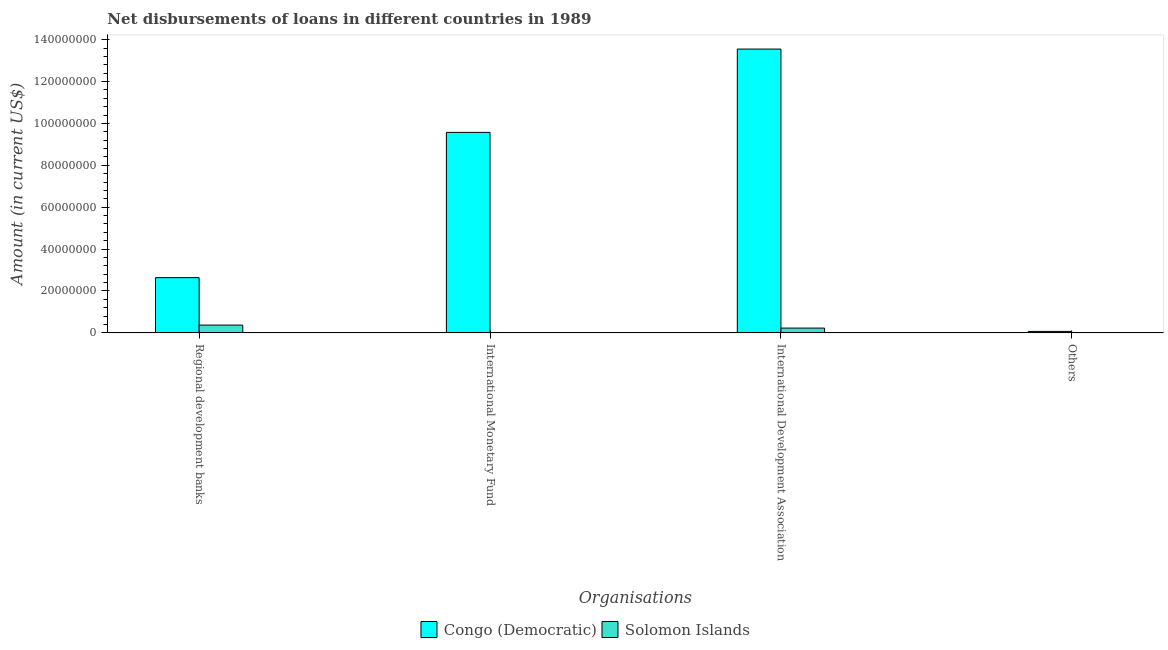Are the number of bars per tick equal to the number of legend labels?
Provide a short and direct response. No. What is the label of the 4th group of bars from the left?
Keep it short and to the point. Others. What is the amount of loan disimbursed by other organisations in Congo (Democratic)?
Offer a very short reply. 6.95e+05. Across all countries, what is the maximum amount of loan disimbursed by other organisations?
Make the answer very short. 6.95e+05. Across all countries, what is the minimum amount of loan disimbursed by regional development banks?
Keep it short and to the point. 3.71e+06. In which country was the amount of loan disimbursed by other organisations maximum?
Keep it short and to the point. Congo (Democratic). What is the total amount of loan disimbursed by regional development banks in the graph?
Provide a succinct answer. 3.01e+07. What is the difference between the amount of loan disimbursed by regional development banks in Solomon Islands and that in Congo (Democratic)?
Ensure brevity in your answer.  -2.27e+07. What is the difference between the amount of loan disimbursed by international development association in Congo (Democratic) and the amount of loan disimbursed by international monetary fund in Solomon Islands?
Your answer should be very brief. 1.35e+08. What is the average amount of loan disimbursed by regional development banks per country?
Provide a short and direct response. 1.50e+07. What is the difference between the amount of loan disimbursed by international development association and amount of loan disimbursed by regional development banks in Congo (Democratic)?
Provide a short and direct response. 1.09e+08. In how many countries, is the amount of loan disimbursed by other organisations greater than 116000000 US$?
Provide a succinct answer. 0. What is the ratio of the amount of loan disimbursed by other organisations in Congo (Democratic) to that in Solomon Islands?
Make the answer very short. 9.79. Is the difference between the amount of loan disimbursed by international development association in Congo (Democratic) and Solomon Islands greater than the difference between the amount of loan disimbursed by other organisations in Congo (Democratic) and Solomon Islands?
Give a very brief answer. Yes. What is the difference between the highest and the second highest amount of loan disimbursed by international development association?
Provide a short and direct response. 1.33e+08. What is the difference between the highest and the lowest amount of loan disimbursed by international monetary fund?
Your response must be concise. 9.57e+07. Is it the case that in every country, the sum of the amount of loan disimbursed by other organisations and amount of loan disimbursed by international development association is greater than the sum of amount of loan disimbursed by international monetary fund and amount of loan disimbursed by regional development banks?
Make the answer very short. Yes. Is it the case that in every country, the sum of the amount of loan disimbursed by regional development banks and amount of loan disimbursed by international monetary fund is greater than the amount of loan disimbursed by international development association?
Provide a succinct answer. No. How many countries are there in the graph?
Give a very brief answer. 2. Are the values on the major ticks of Y-axis written in scientific E-notation?
Keep it short and to the point. No. Does the graph contain any zero values?
Offer a very short reply. Yes. What is the title of the graph?
Give a very brief answer. Net disbursements of loans in different countries in 1989. Does "Bulgaria" appear as one of the legend labels in the graph?
Your answer should be very brief. No. What is the label or title of the X-axis?
Make the answer very short. Organisations. What is the label or title of the Y-axis?
Keep it short and to the point. Amount (in current US$). What is the Amount (in current US$) of Congo (Democratic) in Regional development banks?
Ensure brevity in your answer.  2.64e+07. What is the Amount (in current US$) of Solomon Islands in Regional development banks?
Keep it short and to the point. 3.71e+06. What is the Amount (in current US$) in Congo (Democratic) in International Monetary Fund?
Your answer should be compact. 9.57e+07. What is the Amount (in current US$) of Solomon Islands in International Monetary Fund?
Your answer should be very brief. 0. What is the Amount (in current US$) of Congo (Democratic) in International Development Association?
Your answer should be very brief. 1.35e+08. What is the Amount (in current US$) of Solomon Islands in International Development Association?
Offer a very short reply. 2.28e+06. What is the Amount (in current US$) in Congo (Democratic) in Others?
Keep it short and to the point. 6.95e+05. What is the Amount (in current US$) in Solomon Islands in Others?
Give a very brief answer. 7.10e+04. Across all Organisations, what is the maximum Amount (in current US$) of Congo (Democratic)?
Ensure brevity in your answer.  1.35e+08. Across all Organisations, what is the maximum Amount (in current US$) in Solomon Islands?
Your response must be concise. 3.71e+06. Across all Organisations, what is the minimum Amount (in current US$) of Congo (Democratic)?
Your answer should be compact. 6.95e+05. Across all Organisations, what is the minimum Amount (in current US$) in Solomon Islands?
Your answer should be compact. 0. What is the total Amount (in current US$) of Congo (Democratic) in the graph?
Provide a short and direct response. 2.58e+08. What is the total Amount (in current US$) of Solomon Islands in the graph?
Ensure brevity in your answer.  6.07e+06. What is the difference between the Amount (in current US$) of Congo (Democratic) in Regional development banks and that in International Monetary Fund?
Offer a very short reply. -6.93e+07. What is the difference between the Amount (in current US$) of Congo (Democratic) in Regional development banks and that in International Development Association?
Your response must be concise. -1.09e+08. What is the difference between the Amount (in current US$) in Solomon Islands in Regional development banks and that in International Development Association?
Give a very brief answer. 1.43e+06. What is the difference between the Amount (in current US$) in Congo (Democratic) in Regional development banks and that in Others?
Provide a succinct answer. 2.57e+07. What is the difference between the Amount (in current US$) in Solomon Islands in Regional development banks and that in Others?
Give a very brief answer. 3.64e+06. What is the difference between the Amount (in current US$) in Congo (Democratic) in International Monetary Fund and that in International Development Association?
Keep it short and to the point. -3.98e+07. What is the difference between the Amount (in current US$) of Congo (Democratic) in International Monetary Fund and that in Others?
Keep it short and to the point. 9.50e+07. What is the difference between the Amount (in current US$) in Congo (Democratic) in International Development Association and that in Others?
Keep it short and to the point. 1.35e+08. What is the difference between the Amount (in current US$) of Solomon Islands in International Development Association and that in Others?
Your answer should be very brief. 2.21e+06. What is the difference between the Amount (in current US$) of Congo (Democratic) in Regional development banks and the Amount (in current US$) of Solomon Islands in International Development Association?
Your response must be concise. 2.41e+07. What is the difference between the Amount (in current US$) of Congo (Democratic) in Regional development banks and the Amount (in current US$) of Solomon Islands in Others?
Your answer should be compact. 2.63e+07. What is the difference between the Amount (in current US$) of Congo (Democratic) in International Monetary Fund and the Amount (in current US$) of Solomon Islands in International Development Association?
Provide a short and direct response. 9.34e+07. What is the difference between the Amount (in current US$) of Congo (Democratic) in International Monetary Fund and the Amount (in current US$) of Solomon Islands in Others?
Offer a very short reply. 9.56e+07. What is the difference between the Amount (in current US$) of Congo (Democratic) in International Development Association and the Amount (in current US$) of Solomon Islands in Others?
Your response must be concise. 1.35e+08. What is the average Amount (in current US$) of Congo (Democratic) per Organisations?
Offer a terse response. 6.46e+07. What is the average Amount (in current US$) in Solomon Islands per Organisations?
Ensure brevity in your answer.  1.52e+06. What is the difference between the Amount (in current US$) of Congo (Democratic) and Amount (in current US$) of Solomon Islands in Regional development banks?
Offer a terse response. 2.27e+07. What is the difference between the Amount (in current US$) of Congo (Democratic) and Amount (in current US$) of Solomon Islands in International Development Association?
Provide a short and direct response. 1.33e+08. What is the difference between the Amount (in current US$) of Congo (Democratic) and Amount (in current US$) of Solomon Islands in Others?
Give a very brief answer. 6.24e+05. What is the ratio of the Amount (in current US$) in Congo (Democratic) in Regional development banks to that in International Monetary Fund?
Offer a terse response. 0.28. What is the ratio of the Amount (in current US$) of Congo (Democratic) in Regional development banks to that in International Development Association?
Offer a terse response. 0.19. What is the ratio of the Amount (in current US$) of Solomon Islands in Regional development banks to that in International Development Association?
Ensure brevity in your answer.  1.63. What is the ratio of the Amount (in current US$) in Congo (Democratic) in Regional development banks to that in Others?
Your answer should be compact. 37.94. What is the ratio of the Amount (in current US$) in Solomon Islands in Regional development banks to that in Others?
Give a very brief answer. 52.31. What is the ratio of the Amount (in current US$) in Congo (Democratic) in International Monetary Fund to that in International Development Association?
Offer a very short reply. 0.71. What is the ratio of the Amount (in current US$) of Congo (Democratic) in International Monetary Fund to that in Others?
Offer a terse response. 137.72. What is the ratio of the Amount (in current US$) of Congo (Democratic) in International Development Association to that in Others?
Your answer should be very brief. 194.96. What is the ratio of the Amount (in current US$) in Solomon Islands in International Development Association to that in Others?
Offer a terse response. 32.13. What is the difference between the highest and the second highest Amount (in current US$) of Congo (Democratic)?
Provide a short and direct response. 3.98e+07. What is the difference between the highest and the second highest Amount (in current US$) in Solomon Islands?
Ensure brevity in your answer.  1.43e+06. What is the difference between the highest and the lowest Amount (in current US$) in Congo (Democratic)?
Make the answer very short. 1.35e+08. What is the difference between the highest and the lowest Amount (in current US$) in Solomon Islands?
Provide a succinct answer. 3.71e+06. 